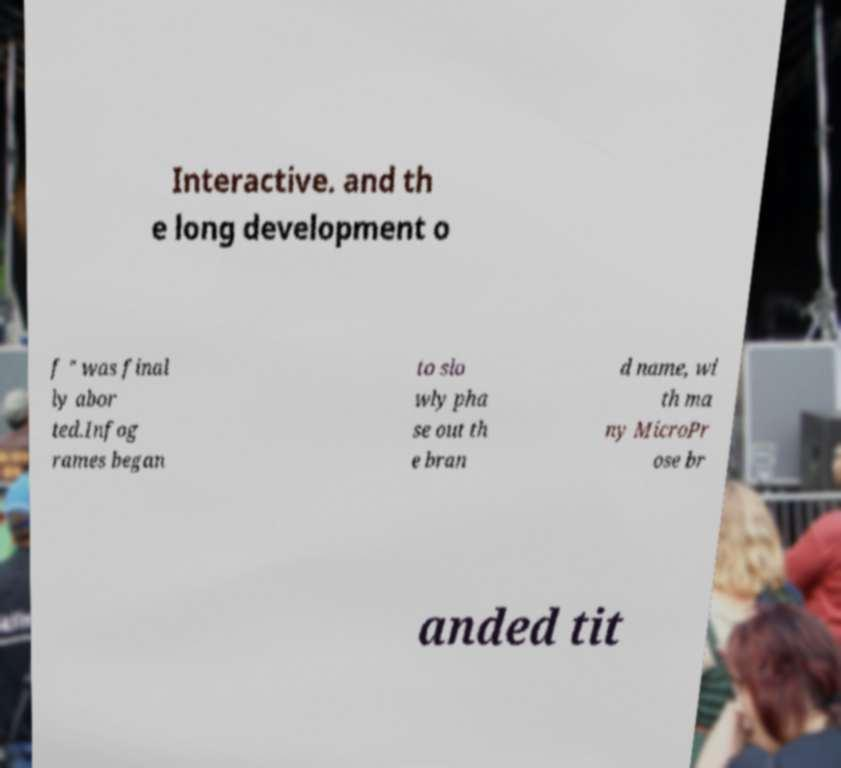What messages or text are displayed in this image? I need them in a readable, typed format. Interactive. and th e long development o f " was final ly abor ted.Infog rames began to slo wly pha se out th e bran d name, wi th ma ny MicroPr ose br anded tit 